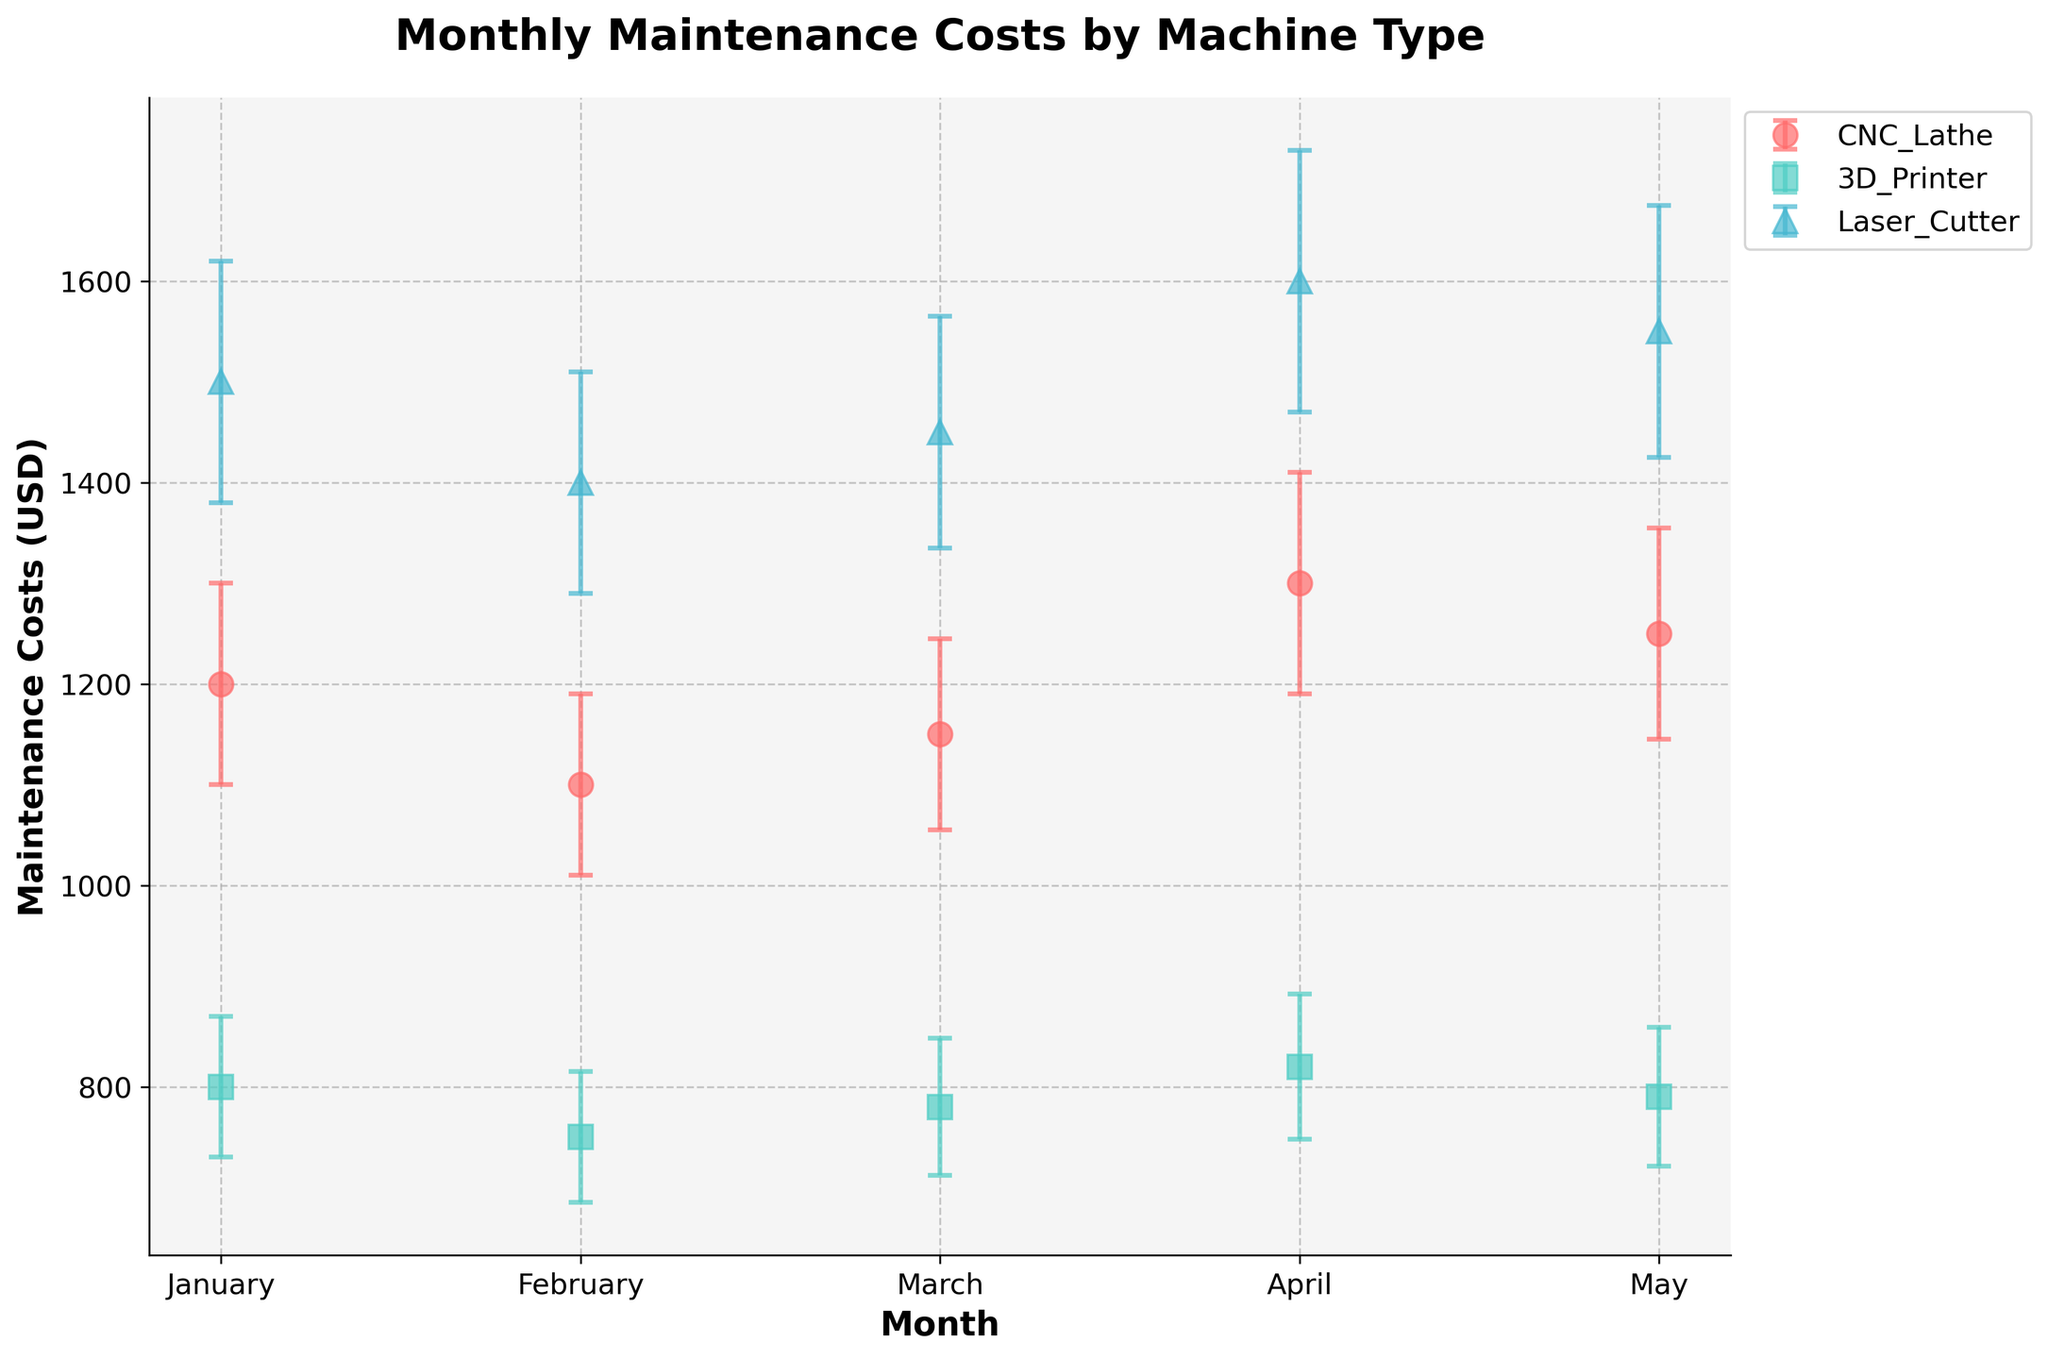What's the title of the plot? The title is displayed at the top of the plot and provides a summary of the visualized data.
Answer: Monthly Maintenance Costs by Machine Type Which machine type has the highest maintenance cost in April? Look for April on the x-axis and observe the y-axis values for all machine types. The Laser Cutter has the highest value in April.
Answer: Laser Cutter How does the maintenance cost of the CNC Lathe in January compare to February? Check the y-axis values for the CNC Lathe in January and February and compare them. January is 1200 USD, and February is 1100 USD, so January's cost is higher.
Answer: Higher in January What is the average maintenance cost for the Laser Cutter across the months provided? The costs for the Laser Cutter are 1500, 1400, 1450, 1600, and 1550 USD. Sum them and divide by the number of months: (1500 + 1400 + 1450 + 1600 + 1550) / 5.
Answer: 1500 USD Which month does the 3D Printer have the most downtime hours? Check the error bars for Avg Downtime Hours for the 3D Printer and identify the month with the highest value. The highest downtime is in April with 11 hours.
Answer: April What is the difference in maintenance costs between the CNC Lathe and the 3D Printer in March? Identify the maintenance costs in March for both machines (CNC Lathe: 1150 USD, 3D Printer: 780 USD). Subtract the 3D Printer's cost from the CNC Lathe's cost: 1150 - 780.
Answer: 370 USD How do the error bars for maintenance costs compare between the CNC Lathe and the Laser Cutter in May? Examine the error bars for both machines in May. The Laser Cutter has a larger error bar (125 USD) compared to the CNC Lathe (105 USD).
Answer: Larger for the Laser Cutter Did the 3D Printer's maintenance cost increase or decrease from January to May? Look at the maintenance costs for the 3D Printer in January (800 USD) and May (790 USD). It decreased by 10 USD.
Answer: Decrease Which machine type has the most consistent maintenance cost over the given months? Observe the fluctuation in the maintenance costs for each machine type. The 3D Printer has the least variation in costs (ranges from 750 to 820 USD).
Answer: 3D Printer 